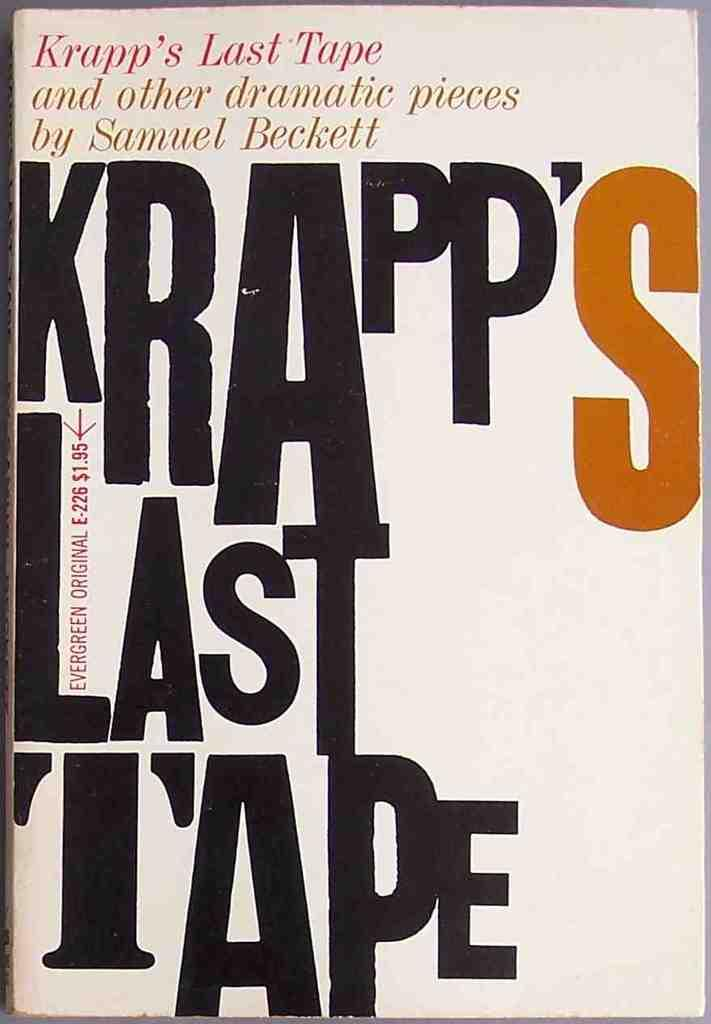<image>
Describe the image concisely. A collection of Samuel Beckett stories in one book. 